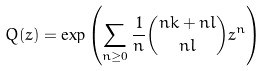Convert formula to latex. <formula><loc_0><loc_0><loc_500><loc_500>Q ( z ) = \exp \left ( \sum _ { n \geq 0 } \frac { 1 } { n } \binom { n k + n l } { n l } z ^ { n } \right )</formula> 